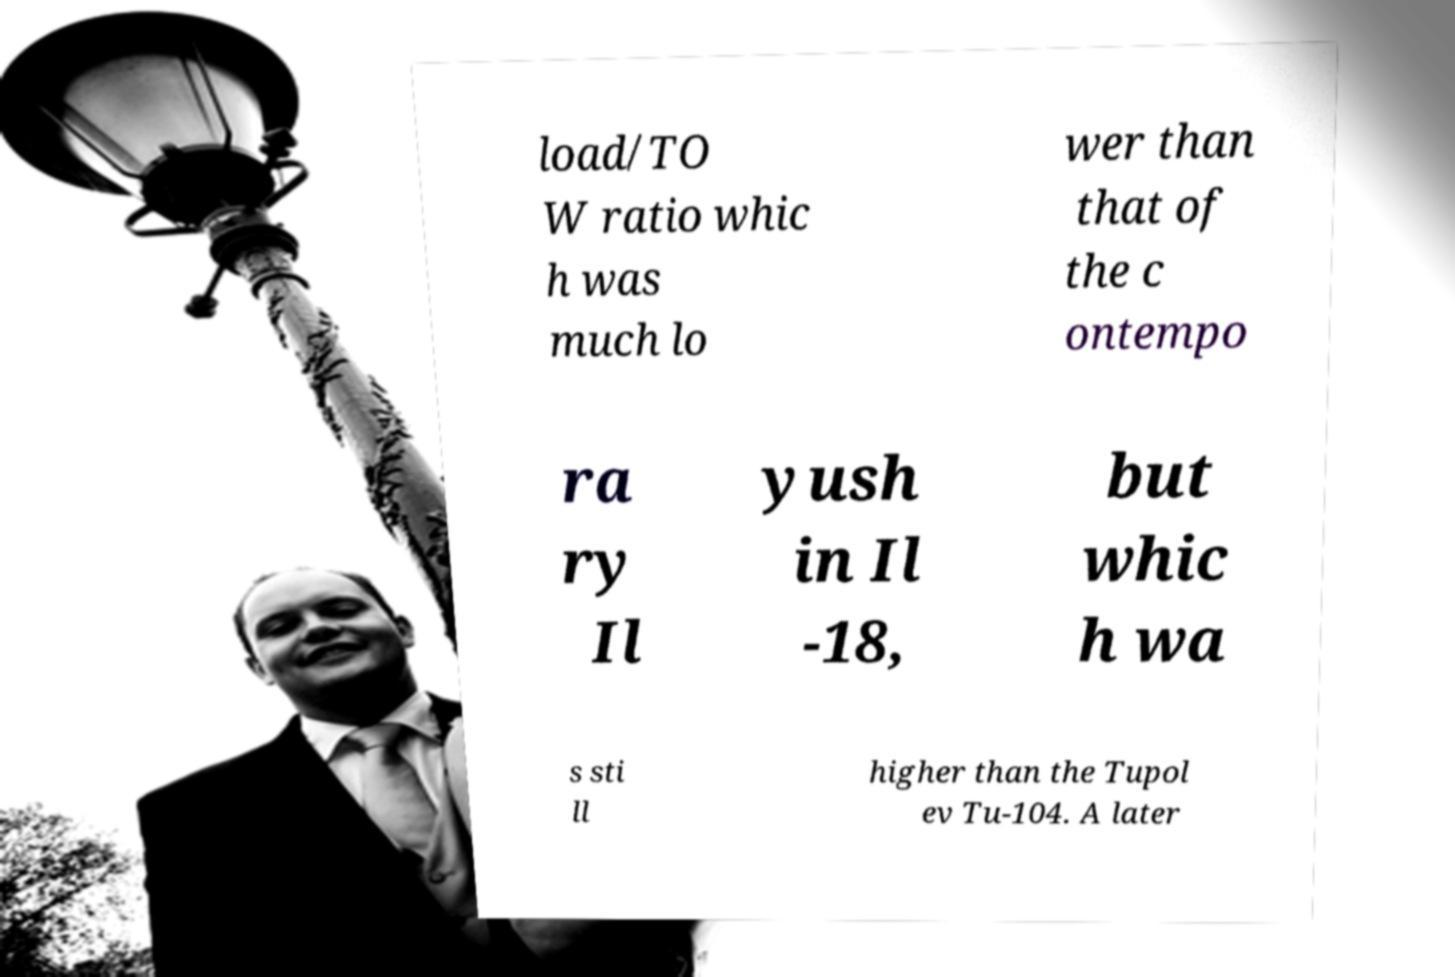Please identify and transcribe the text found in this image. load/TO W ratio whic h was much lo wer than that of the c ontempo ra ry Il yush in Il -18, but whic h wa s sti ll higher than the Tupol ev Tu-104. A later 